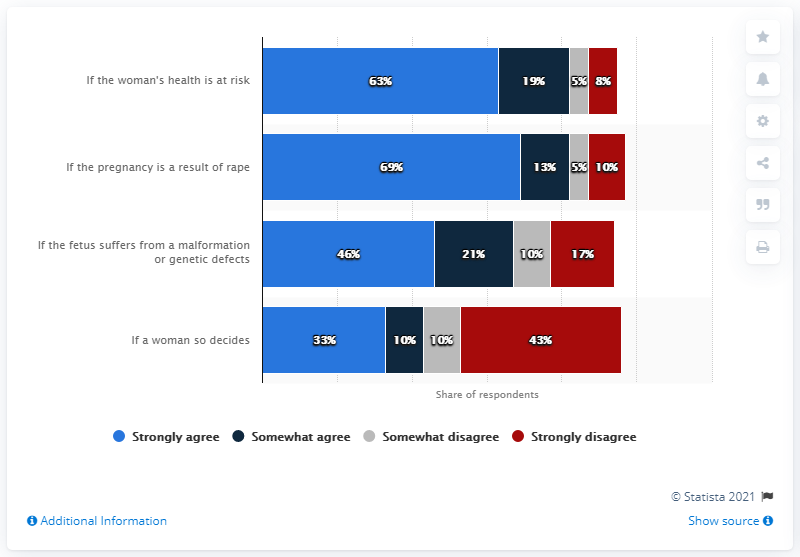Draw attention to some important aspects in this diagram. The chart shows that if the woman's health is at risk and if the pregnancy is a result of rape, both conditions have a high number of strong agree shares. What is the most favorable answer? I strongly agree. 